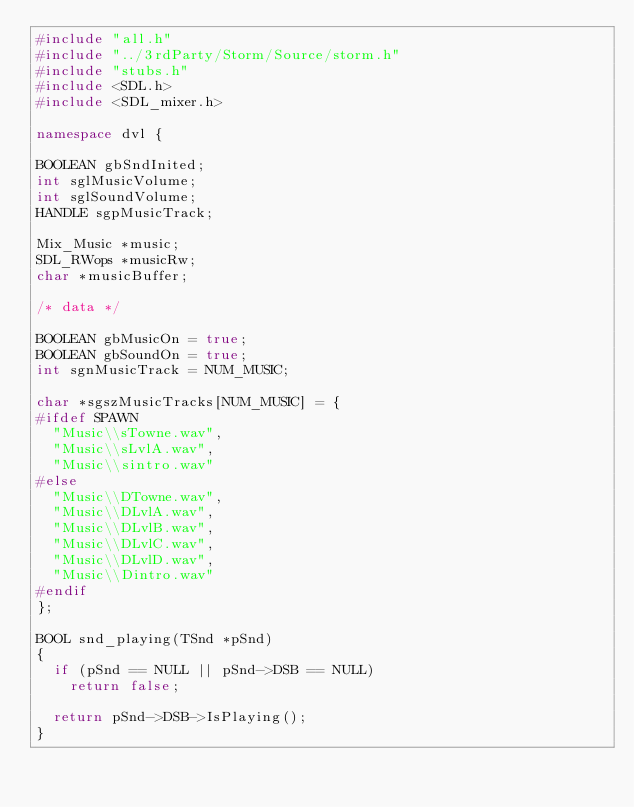Convert code to text. <code><loc_0><loc_0><loc_500><loc_500><_C++_>#include "all.h"
#include "../3rdParty/Storm/Source/storm.h"
#include "stubs.h"
#include <SDL.h>
#include <SDL_mixer.h>

namespace dvl {

BOOLEAN gbSndInited;
int sglMusicVolume;
int sglSoundVolume;
HANDLE sgpMusicTrack;

Mix_Music *music;
SDL_RWops *musicRw;
char *musicBuffer;

/* data */

BOOLEAN gbMusicOn = true;
BOOLEAN gbSoundOn = true;
int sgnMusicTrack = NUM_MUSIC;

char *sgszMusicTracks[NUM_MUSIC] = {
#ifdef SPAWN
	"Music\\sTowne.wav",
	"Music\\sLvlA.wav",
	"Music\\sintro.wav"
#else
	"Music\\DTowne.wav",
	"Music\\DLvlA.wav",
	"Music\\DLvlB.wav",
	"Music\\DLvlC.wav",
	"Music\\DLvlD.wav",
	"Music\\Dintro.wav"
#endif
};

BOOL snd_playing(TSnd *pSnd)
{
	if (pSnd == NULL || pSnd->DSB == NULL)
		return false;

	return pSnd->DSB->IsPlaying();
}
</code> 